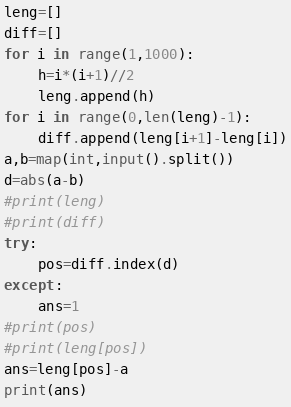Convert code to text. <code><loc_0><loc_0><loc_500><loc_500><_Python_>leng=[]
diff=[]
for i in range(1,1000):
	h=i*(i+1)//2
	leng.append(h)
for i in range(0,len(leng)-1):
	diff.append(leng[i+1]-leng[i])
a,b=map(int,input().split())
d=abs(a-b)
#print(leng)
#print(diff)
try:
	pos=diff.index(d)
except:
	ans=1
#print(pos)
#print(leng[pos])
ans=leng[pos]-a
print(ans)</code> 